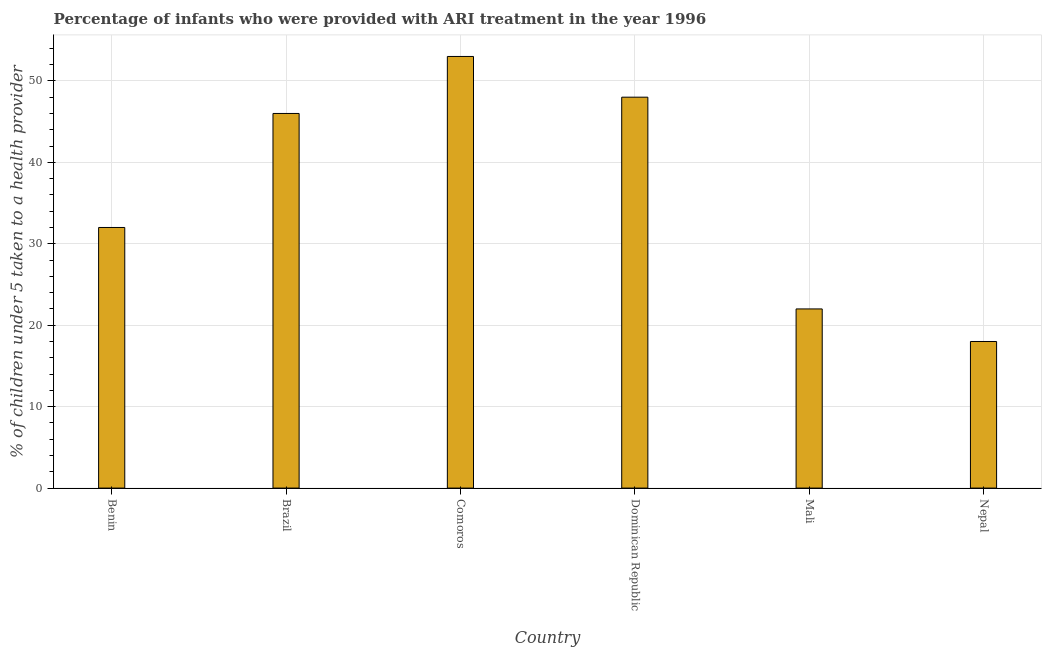Does the graph contain any zero values?
Provide a succinct answer. No. What is the title of the graph?
Your answer should be compact. Percentage of infants who were provided with ARI treatment in the year 1996. What is the label or title of the X-axis?
Offer a terse response. Country. What is the label or title of the Y-axis?
Provide a succinct answer. % of children under 5 taken to a health provider. What is the percentage of children who were provided with ari treatment in Brazil?
Ensure brevity in your answer.  46. Across all countries, what is the maximum percentage of children who were provided with ari treatment?
Your response must be concise. 53. Across all countries, what is the minimum percentage of children who were provided with ari treatment?
Your response must be concise. 18. In which country was the percentage of children who were provided with ari treatment maximum?
Provide a short and direct response. Comoros. In which country was the percentage of children who were provided with ari treatment minimum?
Make the answer very short. Nepal. What is the sum of the percentage of children who were provided with ari treatment?
Your answer should be very brief. 219. What is the median percentage of children who were provided with ari treatment?
Your answer should be very brief. 39. In how many countries, is the percentage of children who were provided with ari treatment greater than 14 %?
Ensure brevity in your answer.  6. What is the ratio of the percentage of children who were provided with ari treatment in Benin to that in Brazil?
Provide a short and direct response. 0.7. Is the percentage of children who were provided with ari treatment in Brazil less than that in Nepal?
Give a very brief answer. No. How many countries are there in the graph?
Your answer should be very brief. 6. What is the difference between two consecutive major ticks on the Y-axis?
Give a very brief answer. 10. Are the values on the major ticks of Y-axis written in scientific E-notation?
Provide a short and direct response. No. What is the % of children under 5 taken to a health provider in Comoros?
Offer a terse response. 53. What is the % of children under 5 taken to a health provider in Dominican Republic?
Offer a terse response. 48. What is the % of children under 5 taken to a health provider in Nepal?
Your response must be concise. 18. What is the difference between the % of children under 5 taken to a health provider in Benin and Dominican Republic?
Keep it short and to the point. -16. What is the difference between the % of children under 5 taken to a health provider in Benin and Mali?
Give a very brief answer. 10. What is the difference between the % of children under 5 taken to a health provider in Brazil and Comoros?
Your response must be concise. -7. What is the difference between the % of children under 5 taken to a health provider in Comoros and Dominican Republic?
Ensure brevity in your answer.  5. What is the difference between the % of children under 5 taken to a health provider in Comoros and Mali?
Offer a very short reply. 31. What is the difference between the % of children under 5 taken to a health provider in Dominican Republic and Mali?
Give a very brief answer. 26. What is the difference between the % of children under 5 taken to a health provider in Mali and Nepal?
Your answer should be very brief. 4. What is the ratio of the % of children under 5 taken to a health provider in Benin to that in Brazil?
Provide a short and direct response. 0.7. What is the ratio of the % of children under 5 taken to a health provider in Benin to that in Comoros?
Keep it short and to the point. 0.6. What is the ratio of the % of children under 5 taken to a health provider in Benin to that in Dominican Republic?
Provide a short and direct response. 0.67. What is the ratio of the % of children under 5 taken to a health provider in Benin to that in Mali?
Provide a short and direct response. 1.46. What is the ratio of the % of children under 5 taken to a health provider in Benin to that in Nepal?
Your answer should be compact. 1.78. What is the ratio of the % of children under 5 taken to a health provider in Brazil to that in Comoros?
Give a very brief answer. 0.87. What is the ratio of the % of children under 5 taken to a health provider in Brazil to that in Dominican Republic?
Your answer should be compact. 0.96. What is the ratio of the % of children under 5 taken to a health provider in Brazil to that in Mali?
Offer a very short reply. 2.09. What is the ratio of the % of children under 5 taken to a health provider in Brazil to that in Nepal?
Make the answer very short. 2.56. What is the ratio of the % of children under 5 taken to a health provider in Comoros to that in Dominican Republic?
Your answer should be compact. 1.1. What is the ratio of the % of children under 5 taken to a health provider in Comoros to that in Mali?
Give a very brief answer. 2.41. What is the ratio of the % of children under 5 taken to a health provider in Comoros to that in Nepal?
Provide a short and direct response. 2.94. What is the ratio of the % of children under 5 taken to a health provider in Dominican Republic to that in Mali?
Keep it short and to the point. 2.18. What is the ratio of the % of children under 5 taken to a health provider in Dominican Republic to that in Nepal?
Your answer should be very brief. 2.67. What is the ratio of the % of children under 5 taken to a health provider in Mali to that in Nepal?
Your response must be concise. 1.22. 